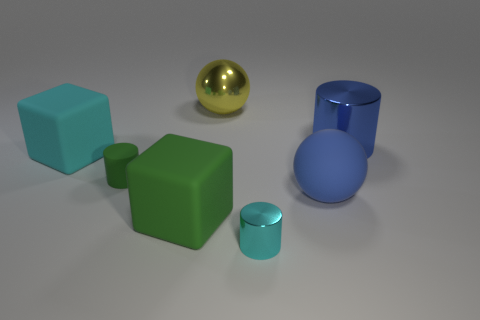Is the material of the tiny green object the same as the cyan object that is to the right of the large yellow sphere?
Offer a very short reply. No. There is a big sphere to the left of the big ball in front of the shiny ball; how many matte balls are behind it?
Give a very brief answer. 0. How many blue things are tiny objects or cubes?
Keep it short and to the point. 0. What shape is the shiny object that is on the left side of the small cyan metallic object?
Offer a terse response. Sphere. There is another shiny sphere that is the same size as the blue ball; what color is it?
Offer a terse response. Yellow. Do the small cyan metallic thing and the big thing that is right of the blue rubber sphere have the same shape?
Your answer should be very brief. Yes. What is the material of the large thing behind the shiny thing that is right of the metallic object that is in front of the cyan matte block?
Make the answer very short. Metal. How many big things are cyan metal cylinders or shiny things?
Provide a succinct answer. 2. How many other objects are the same size as the green cylinder?
Make the answer very short. 1. There is a rubber object right of the large green block; is its shape the same as the yellow metal object?
Make the answer very short. Yes. 